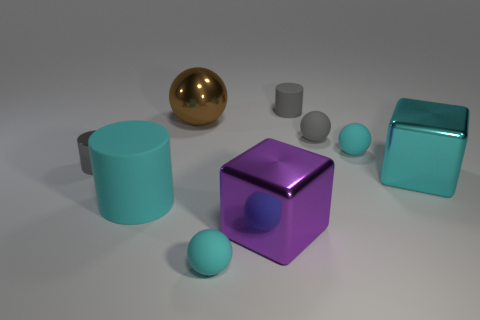What number of other things are the same color as the large matte thing?
Ensure brevity in your answer.  3. There is a ball that is both in front of the gray matte sphere and behind the large purple thing; what is its color?
Provide a succinct answer. Cyan. Is the number of tiny metal things less than the number of big purple cylinders?
Offer a very short reply. No. Do the large shiny sphere and the cylinder behind the gray metallic thing have the same color?
Make the answer very short. No. Are there the same number of small cyan matte balls behind the purple object and small gray rubber spheres that are on the right side of the brown shiny object?
Give a very brief answer. Yes. What number of gray matte things have the same shape as the purple thing?
Your response must be concise. 0. Are any large cyan cylinders visible?
Give a very brief answer. Yes. Do the purple cube and the cyan sphere that is behind the tiny metallic object have the same material?
Provide a short and direct response. No. What is the material of the cyan cube that is the same size as the brown ball?
Ensure brevity in your answer.  Metal. Is there a large thing made of the same material as the large brown sphere?
Keep it short and to the point. Yes. 